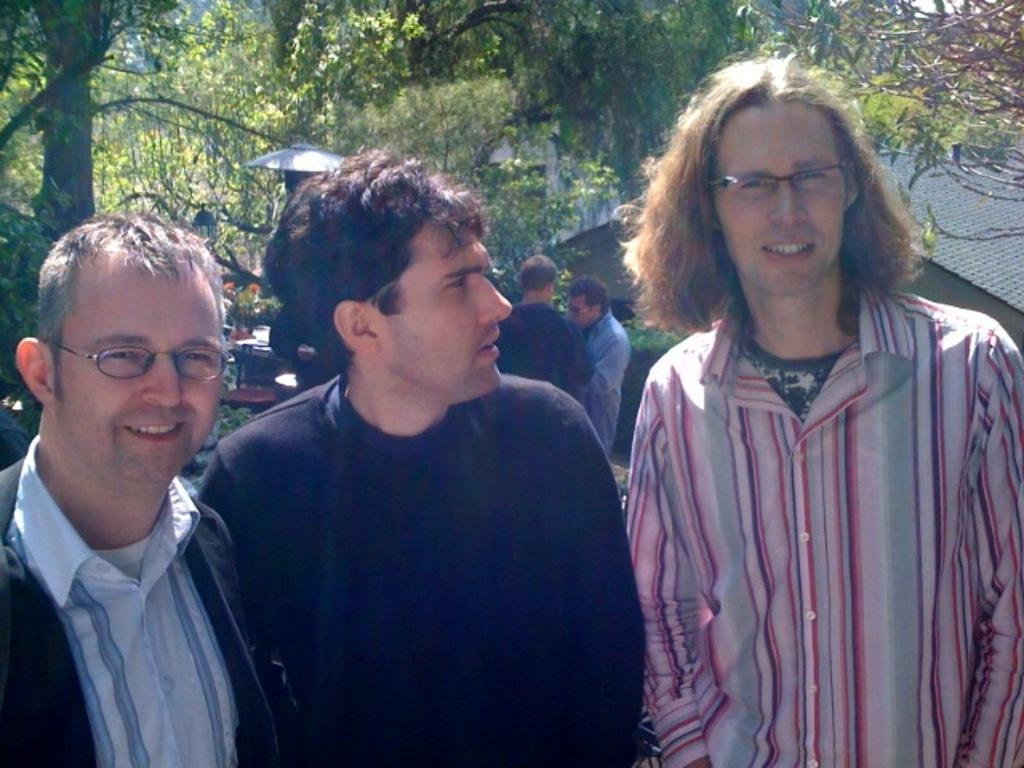How many people are visible in the image? There are three persons standing in the image. What can be seen in the background of the image? There is a house, a table, a chair, two persons, a light, and trees in the background of the image. What type of cloth is being used as payment in the image? There is no cloth or payment present in the image. What color is the brick used to build the house in the image? There is no brick visible in the image, as the house is in the background and the focus is on the three persons standing. 